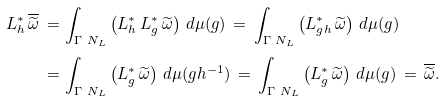Convert formula to latex. <formula><loc_0><loc_0><loc_500><loc_500>L _ { h } ^ { * } \, \overline { \widetilde { \omega } } \, = \, & \int _ { { \Gamma } \ N _ { L } } \left ( L _ { h } ^ { * } \, L _ { g } ^ { * } \, \widetilde { \omega } \right ) \, d \mu ( g ) \, = \, \int _ { { \Gamma } \ N _ { L } } \left ( L _ { g h } ^ { * } \, \widetilde { \omega } \right ) \, d \mu ( g ) \\ = \, & \int _ { { \Gamma } \ N _ { L } } \left ( L _ { g } ^ { * } \, \widetilde { \omega } \right ) \, d \mu ( g h ^ { - 1 } ) \, = \, \int _ { { \Gamma } \ N _ { L } } \left ( L _ { g } ^ { * } \, \widetilde { \omega } \right ) \, d \mu ( g ) \, = \, \overline { \widetilde { \omega } } .</formula> 